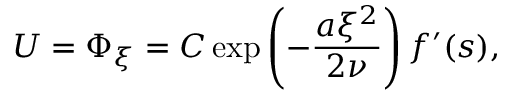<formula> <loc_0><loc_0><loc_500><loc_500>U = \Phi _ { \xi } = C \exp \left ( - \frac { a \xi ^ { 2 } } { 2 \nu } \right ) f ^ { \prime } ( s ) ,</formula> 